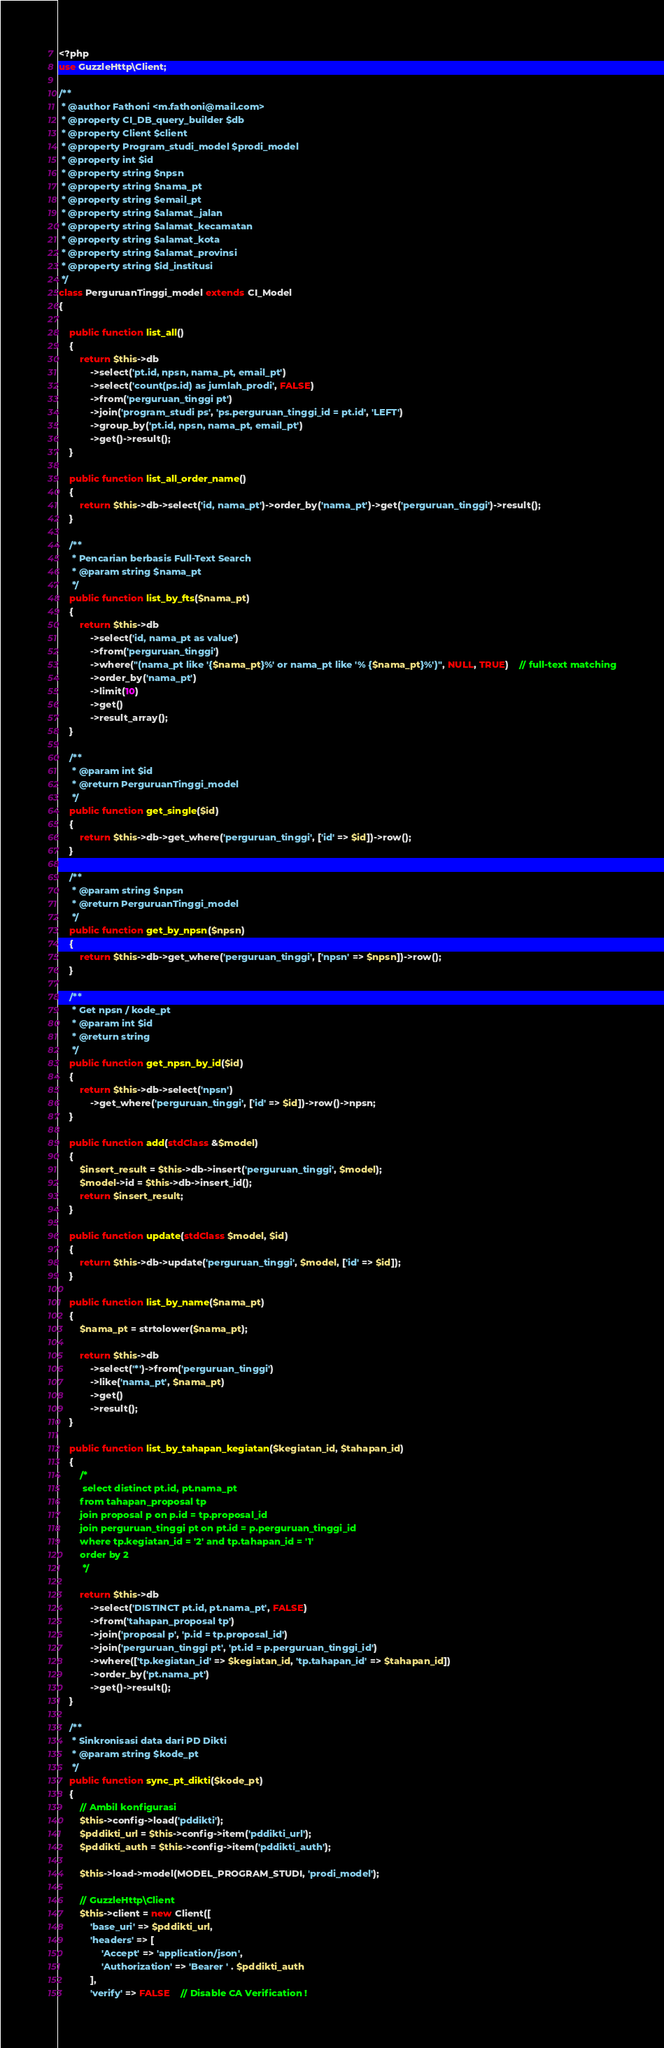<code> <loc_0><loc_0><loc_500><loc_500><_PHP_><?php
use GuzzleHttp\Client;

/**
 * @author Fathoni <m.fathoni@mail.com>
 * @property CI_DB_query_builder $db 
 * @property Client $client
 * @property Program_studi_model $prodi_model
 * @property int $id
 * @property string $npsn
 * @property string $nama_pt
 * @property string $email_pt
 * @property string $alamat_jalan
 * @property string $alamat_kecamatan
 * @property string $alamat_kota
 * @property string $alamat_provinsi
 * @property string $id_institusi
 */
class PerguruanTinggi_model extends CI_Model
{
	
	public function list_all()
	{
		return $this->db
			->select('pt.id, npsn, nama_pt, email_pt')
			->select('count(ps.id) as jumlah_prodi', FALSE)
			->from('perguruan_tinggi pt')
			->join('program_studi ps', 'ps.perguruan_tinggi_id = pt.id', 'LEFT')
			->group_by('pt.id, npsn, nama_pt, email_pt')
			->get()->result();
	}
	
	public function list_all_order_name()
	{
		return $this->db->select('id, nama_pt')->order_by('nama_pt')->get('perguruan_tinggi')->result();
	}
	
	/**
	 * Pencarian berbasis Full-Text Search
	 * @param string $nama_pt
	 */
	public function list_by_fts($nama_pt)
	{
		return $this->db
			->select('id, nama_pt as value')
			->from('perguruan_tinggi')
			->where("(nama_pt like '{$nama_pt}%' or nama_pt like '% {$nama_pt}%')", NULL, TRUE)	// full-text matching
			->order_by('nama_pt')
			->limit(10)
			->get()
			->result_array();
	}
	
	/**
	 * @param int $id
	 * @return PerguruanTinggi_model
	 */
	public function get_single($id)
	{
		return $this->db->get_where('perguruan_tinggi', ['id' => $id])->row();
	}
	
	/**
	 * @param string $npsn
	 * @return PerguruanTinggi_model
	 */
	public function get_by_npsn($npsn)
	{
		return $this->db->get_where('perguruan_tinggi', ['npsn' => $npsn])->row();
	}
	
	/**
	 * Get npsn / kode_pt
	 * @param int $id
	 * @return string
	 */
	public function get_npsn_by_id($id)
	{
		return $this->db->select('npsn')
			->get_where('perguruan_tinggi', ['id' => $id])->row()->npsn;
	}
	
	public function add(stdClass &$model)
	{
		$insert_result = $this->db->insert('perguruan_tinggi', $model);
		$model->id = $this->db->insert_id();
		return $insert_result;
	}
	
	public function update(stdClass $model, $id)
	{
		return $this->db->update('perguruan_tinggi', $model, ['id' => $id]);
	}
	
	public function list_by_name($nama_pt)
	{
		$nama_pt = strtolower($nama_pt);
		
		return $this->db
			->select('*')->from('perguruan_tinggi')
			->like('nama_pt', $nama_pt)
			->get()
			->result();
	}
	
	public function list_by_tahapan_kegiatan($kegiatan_id, $tahapan_id)
	{
		/*
		 select distinct pt.id, pt.nama_pt
		from tahapan_proposal tp
		join proposal p on p.id = tp.proposal_id
		join perguruan_tinggi pt on pt.id = p.perguruan_tinggi_id
		where tp.kegiatan_id = '2' and tp.tahapan_id = '1'
		order by 2
		 */
		
		return $this->db
			->select('DISTINCT pt.id, pt.nama_pt', FALSE)
			->from('tahapan_proposal tp')
			->join('proposal p', 'p.id = tp.proposal_id')
			->join('perguruan_tinggi pt', 'pt.id = p.perguruan_tinggi_id')
			->where(['tp.kegiatan_id' => $kegiatan_id, 'tp.tahapan_id' => $tahapan_id])
			->order_by('pt.nama_pt')
			->get()->result();
	}
	
	/**
	 * Sinkronisasi data dari PD Dikti
	 * @param string $kode_pt
	 */
	public function sync_pt_dikti($kode_pt)
	{
		// Ambil konfigurasi
		$this->config->load('pddikti');
		$pddikti_url = $this->config->item('pddikti_url');
		$pddikti_auth = $this->config->item('pddikti_auth');
		
		$this->load->model(MODEL_PROGRAM_STUDI, 'prodi_model');

		// GuzzleHttp\Client
		$this->client = new Client([
			'base_uri' => $pddikti_url,
			'headers' => [
				'Accept' => 'application/json',
				'Authorization' => 'Bearer ' . $pddikti_auth
			],
			'verify' => FALSE	// Disable CA Verification !</code> 